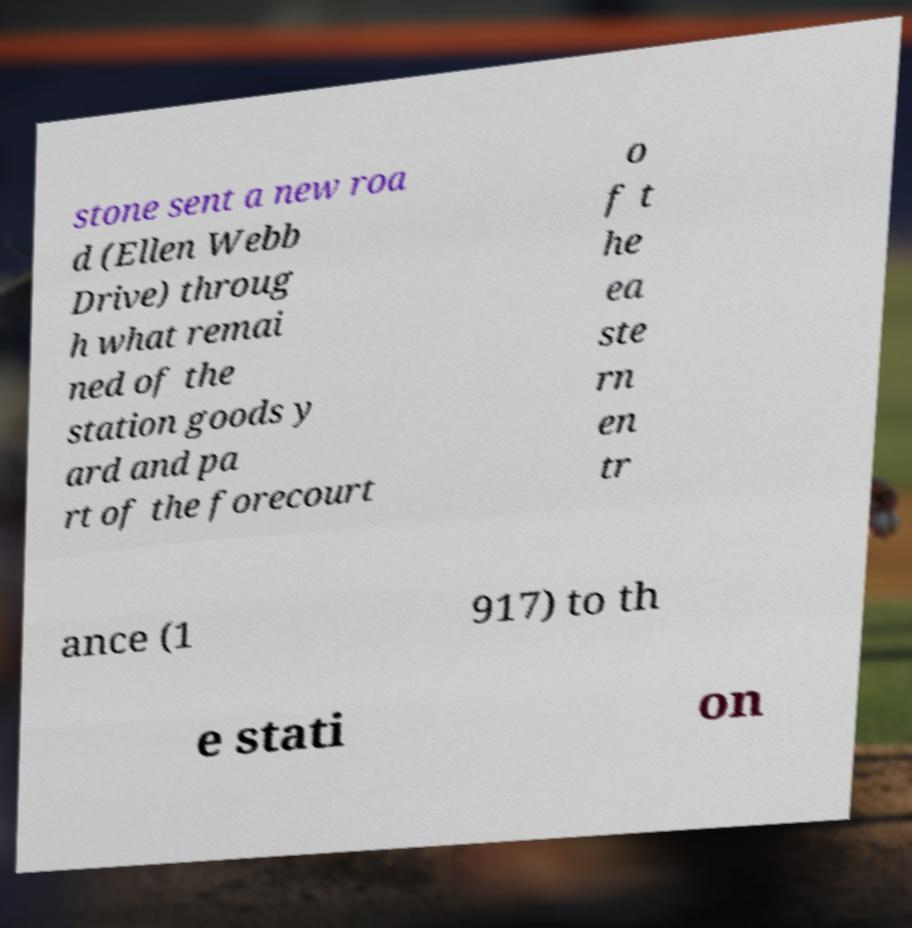Please identify and transcribe the text found in this image. stone sent a new roa d (Ellen Webb Drive) throug h what remai ned of the station goods y ard and pa rt of the forecourt o f t he ea ste rn en tr ance (1 917) to th e stati on 